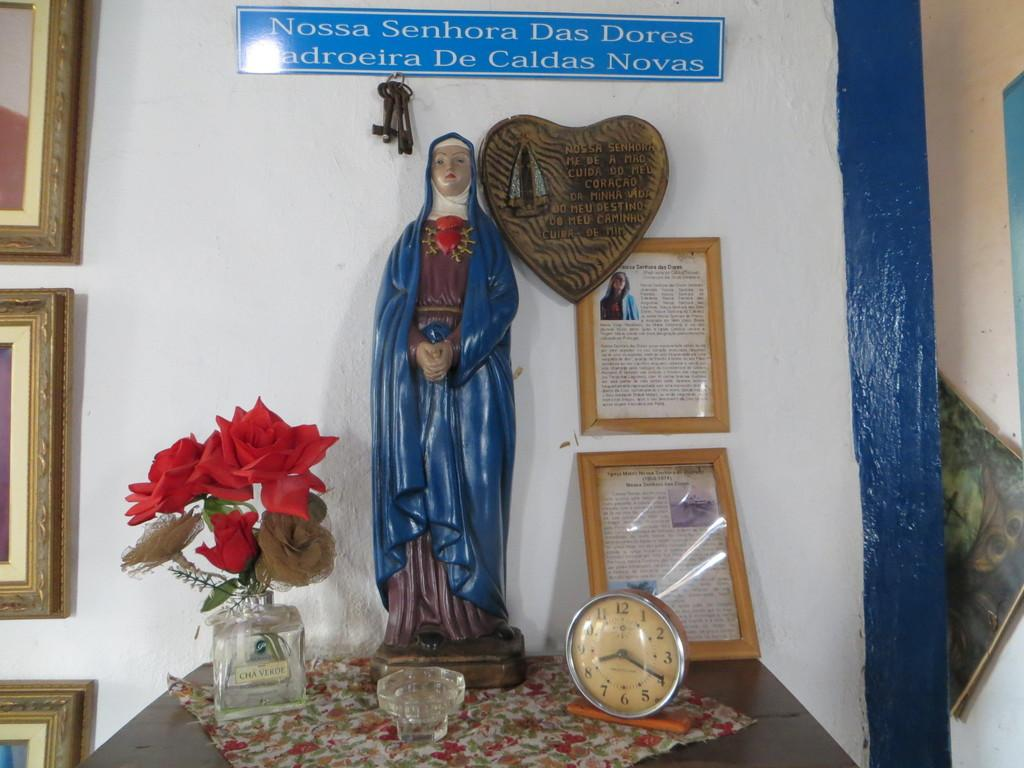<image>
Share a concise interpretation of the image provided. Statue of Mary with writing on top saying Nossa Senhora Das Dores Maroeira De Caldas Novas 